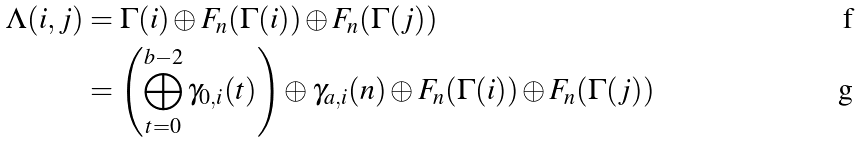<formula> <loc_0><loc_0><loc_500><loc_500>\Lambda ( i , j ) & = \Gamma ( i ) \oplus F _ { n } ( \Gamma ( i ) ) \oplus F _ { n } ( \Gamma ( j ) ) \\ & = \left ( \bigoplus _ { t = 0 } ^ { b - 2 } \gamma _ { 0 , i } ( t ) \right ) \oplus \gamma _ { a , i } ( n ) \oplus F _ { n } ( \Gamma ( i ) ) \oplus F _ { n } ( \Gamma ( j ) )</formula> 